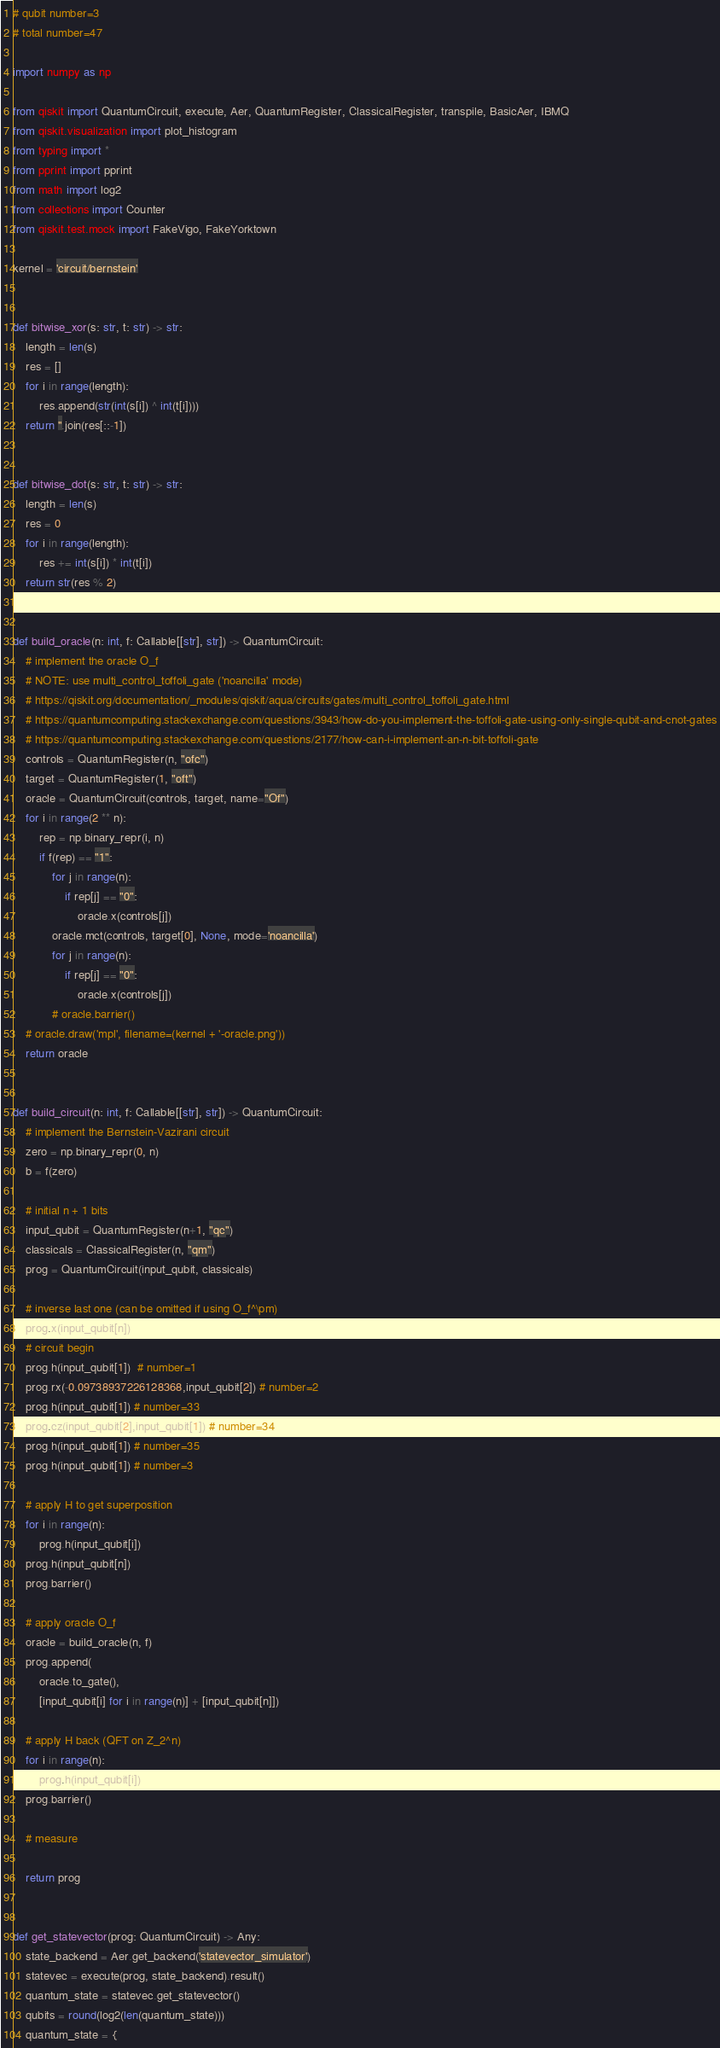Convert code to text. <code><loc_0><loc_0><loc_500><loc_500><_Python_># qubit number=3
# total number=47

import numpy as np

from qiskit import QuantumCircuit, execute, Aer, QuantumRegister, ClassicalRegister, transpile, BasicAer, IBMQ
from qiskit.visualization import plot_histogram
from typing import *
from pprint import pprint
from math import log2
from collections import Counter
from qiskit.test.mock import FakeVigo, FakeYorktown

kernel = 'circuit/bernstein'


def bitwise_xor(s: str, t: str) -> str:
    length = len(s)
    res = []
    for i in range(length):
        res.append(str(int(s[i]) ^ int(t[i])))
    return ''.join(res[::-1])


def bitwise_dot(s: str, t: str) -> str:
    length = len(s)
    res = 0
    for i in range(length):
        res += int(s[i]) * int(t[i])
    return str(res % 2)


def build_oracle(n: int, f: Callable[[str], str]) -> QuantumCircuit:
    # implement the oracle O_f
    # NOTE: use multi_control_toffoli_gate ('noancilla' mode)
    # https://qiskit.org/documentation/_modules/qiskit/aqua/circuits/gates/multi_control_toffoli_gate.html
    # https://quantumcomputing.stackexchange.com/questions/3943/how-do-you-implement-the-toffoli-gate-using-only-single-qubit-and-cnot-gates
    # https://quantumcomputing.stackexchange.com/questions/2177/how-can-i-implement-an-n-bit-toffoli-gate
    controls = QuantumRegister(n, "ofc")
    target = QuantumRegister(1, "oft")
    oracle = QuantumCircuit(controls, target, name="Of")
    for i in range(2 ** n):
        rep = np.binary_repr(i, n)
        if f(rep) == "1":
            for j in range(n):
                if rep[j] == "0":
                    oracle.x(controls[j])
            oracle.mct(controls, target[0], None, mode='noancilla')
            for j in range(n):
                if rep[j] == "0":
                    oracle.x(controls[j])
            # oracle.barrier()
    # oracle.draw('mpl', filename=(kernel + '-oracle.png'))
    return oracle


def build_circuit(n: int, f: Callable[[str], str]) -> QuantumCircuit:
    # implement the Bernstein-Vazirani circuit
    zero = np.binary_repr(0, n)
    b = f(zero)

    # initial n + 1 bits
    input_qubit = QuantumRegister(n+1, "qc")
    classicals = ClassicalRegister(n, "qm")
    prog = QuantumCircuit(input_qubit, classicals)

    # inverse last one (can be omitted if using O_f^\pm)
    prog.x(input_qubit[n])
    # circuit begin
    prog.h(input_qubit[1])  # number=1
    prog.rx(-0.09738937226128368,input_qubit[2]) # number=2
    prog.h(input_qubit[1]) # number=33
    prog.cz(input_qubit[2],input_qubit[1]) # number=34
    prog.h(input_qubit[1]) # number=35
    prog.h(input_qubit[1]) # number=3

    # apply H to get superposition
    for i in range(n):
        prog.h(input_qubit[i])
    prog.h(input_qubit[n])
    prog.barrier()

    # apply oracle O_f
    oracle = build_oracle(n, f)
    prog.append(
        oracle.to_gate(),
        [input_qubit[i] for i in range(n)] + [input_qubit[n]])

    # apply H back (QFT on Z_2^n)
    for i in range(n):
        prog.h(input_qubit[i])
    prog.barrier()

    # measure

    return prog


def get_statevector(prog: QuantumCircuit) -> Any:
    state_backend = Aer.get_backend('statevector_simulator')
    statevec = execute(prog, state_backend).result()
    quantum_state = statevec.get_statevector()
    qubits = round(log2(len(quantum_state)))
    quantum_state = {</code> 